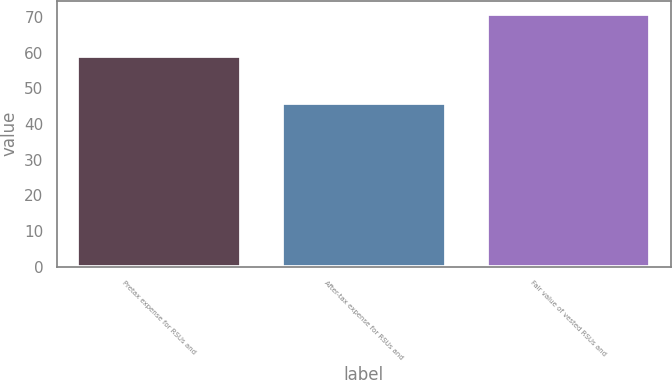Convert chart. <chart><loc_0><loc_0><loc_500><loc_500><bar_chart><fcel>Pretax expense for RSUs and<fcel>After-tax expense for RSUs and<fcel>Fair value of vested RSUs and<nl><fcel>59<fcel>46<fcel>71<nl></chart> 